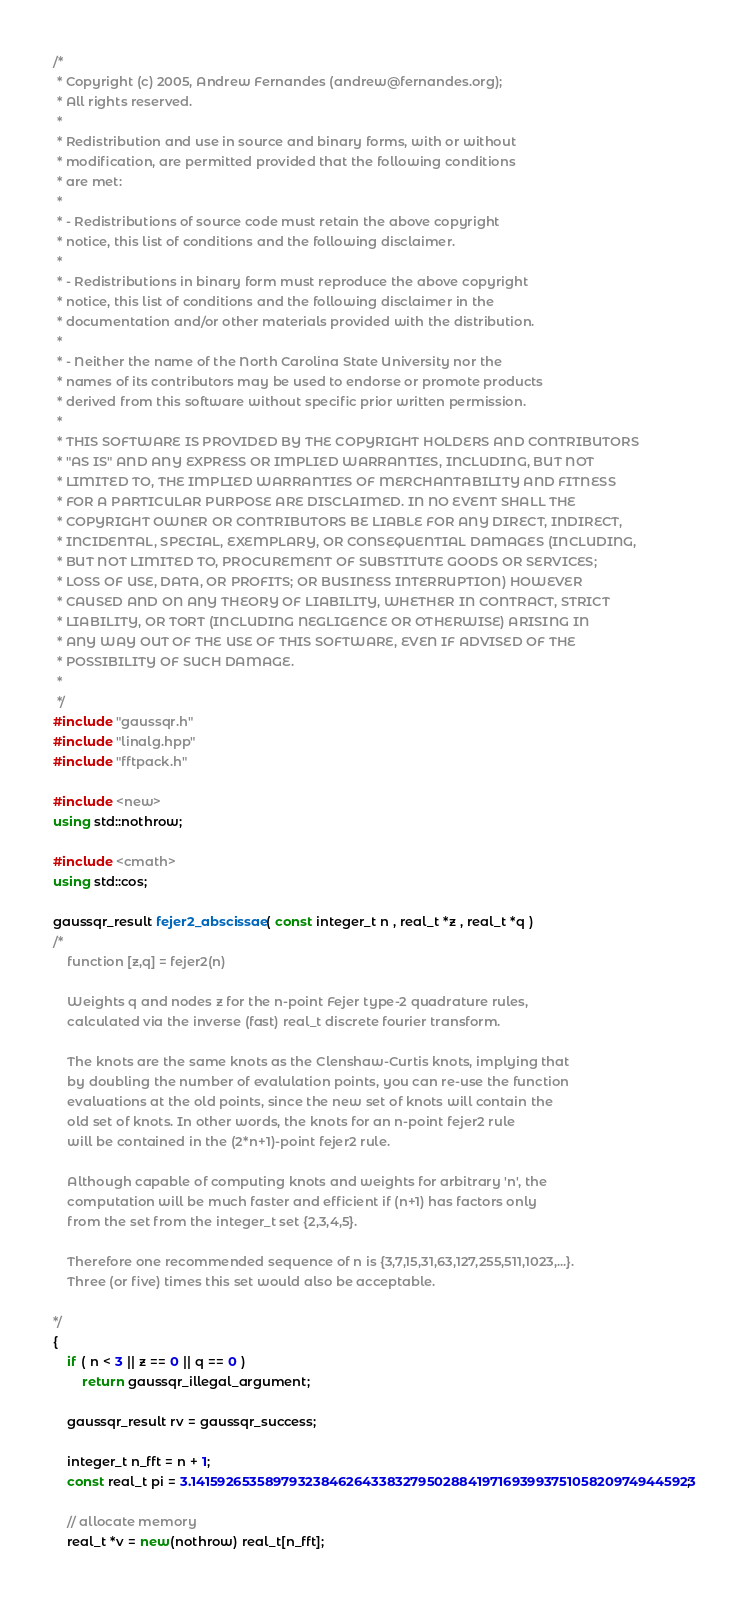<code> <loc_0><loc_0><loc_500><loc_500><_C++_>/*
 * Copyright (c) 2005, Andrew Fernandes (andrew@fernandes.org);
 * All rights reserved.
 * 
 * Redistribution and use in source and binary forms, with or without
 * modification, are permitted provided that the following conditions
 * are met:
 * 
 * - Redistributions of source code must retain the above copyright
 * notice, this list of conditions and the following disclaimer.
 * 
 * - Redistributions in binary form must reproduce the above copyright
 * notice, this list of conditions and the following disclaimer in the
 * documentation and/or other materials provided with the distribution.
 * 
 * - Neither the name of the North Carolina State University nor the
 * names of its contributors may be used to endorse or promote products
 * derived from this software without specific prior written permission.
 * 
 * THIS SOFTWARE IS PROVIDED BY THE COPYRIGHT HOLDERS AND CONTRIBUTORS
 * "AS IS" AND ANY EXPRESS OR IMPLIED WARRANTIES, INCLUDING, BUT NOT
 * LIMITED TO, THE IMPLIED WARRANTIES OF MERCHANTABILITY AND FITNESS
 * FOR A PARTICULAR PURPOSE ARE DISCLAIMED. IN NO EVENT SHALL THE
 * COPYRIGHT OWNER OR CONTRIBUTORS BE LIABLE FOR ANY DIRECT, INDIRECT,
 * INCIDENTAL, SPECIAL, EXEMPLARY, OR CONSEQUENTIAL DAMAGES (INCLUDING,
 * BUT NOT LIMITED TO, PROCUREMENT OF SUBSTITUTE GOODS OR SERVICES;
 * LOSS OF USE, DATA, OR PROFITS; OR BUSINESS INTERRUPTION) HOWEVER
 * CAUSED AND ON ANY THEORY OF LIABILITY, WHETHER IN CONTRACT, STRICT
 * LIABILITY, OR TORT (INCLUDING NEGLIGENCE OR OTHERWISE) ARISING IN
 * ANY WAY OUT OF THE USE OF THIS SOFTWARE, EVEN IF ADVISED OF THE
 * POSSIBILITY OF SUCH DAMAGE.
 *
 */
#include "gaussqr.h"
#include "linalg.hpp"
#include "fftpack.h"

#include <new>
using std::nothrow;

#include <cmath>
using std::cos;

gaussqr_result fejer2_abscissae( const integer_t n , real_t *z , real_t *q )
/*
	function [z,q] = fejer2(n)

	Weights q and nodes z for the n-point Fejer type-2 quadrature rules,
	calculated via the inverse (fast) real_t discrete fourier transform.

	The knots are the same knots as the Clenshaw-Curtis knots, implying that
	by doubling the number of evalulation points, you can re-use the function
	evaluations at the old points, since the new set of knots will contain the
	old set of knots. In other words, the knots for an n-point fejer2 rule
	will be contained in the (2*n+1)-point fejer2 rule.
 
	Although capable of computing knots and weights for arbitrary 'n', the
	computation will be much faster and efficient if (n+1) has factors only
	from the set from the integer_t set {2,3,4,5}.
	
	Therefore one recommended sequence of n is {3,7,15,31,63,127,255,511,1023,...}.
	Three (or five) times this set would also be acceptable.
  
*/
{
	if ( n < 3 || z == 0 || q == 0 )
		return gaussqr_illegal_argument;
	
	gaussqr_result rv = gaussqr_success;

	integer_t n_fft = n + 1;
	const real_t pi = 3.1415926535897932384626433832795028841971693993751058209749445923;

	// allocate memory
	real_t *v = new(nothrow) real_t[n_fft];</code> 